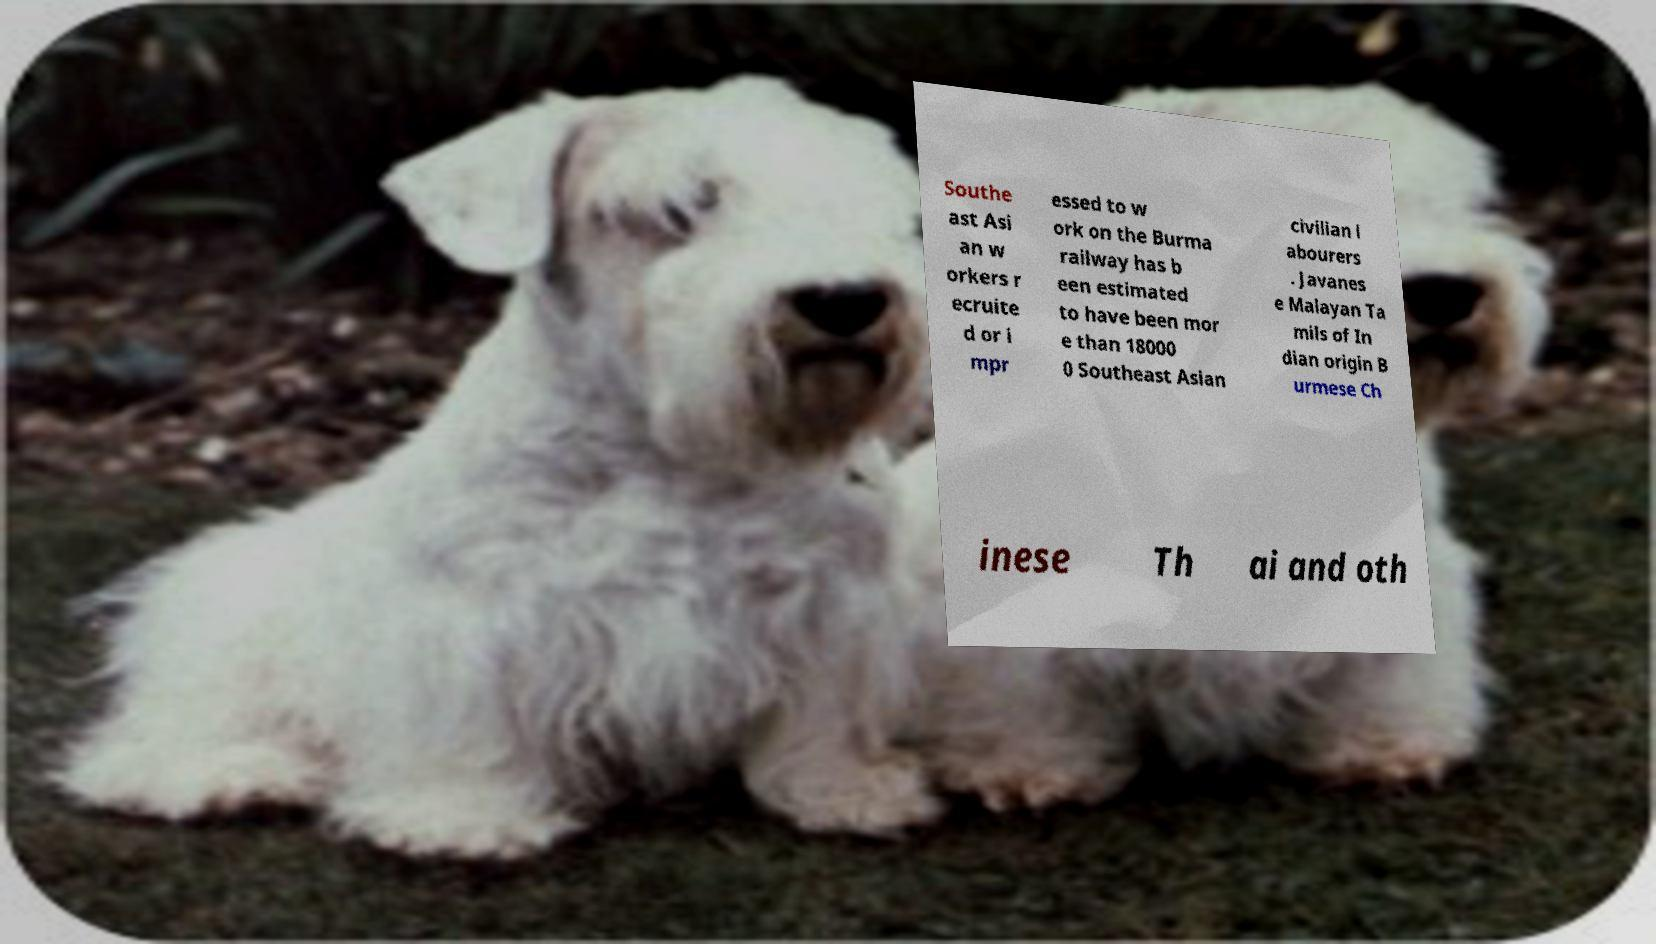Could you extract and type out the text from this image? Southe ast Asi an w orkers r ecruite d or i mpr essed to w ork on the Burma railway has b een estimated to have been mor e than 18000 0 Southeast Asian civilian l abourers . Javanes e Malayan Ta mils of In dian origin B urmese Ch inese Th ai and oth 